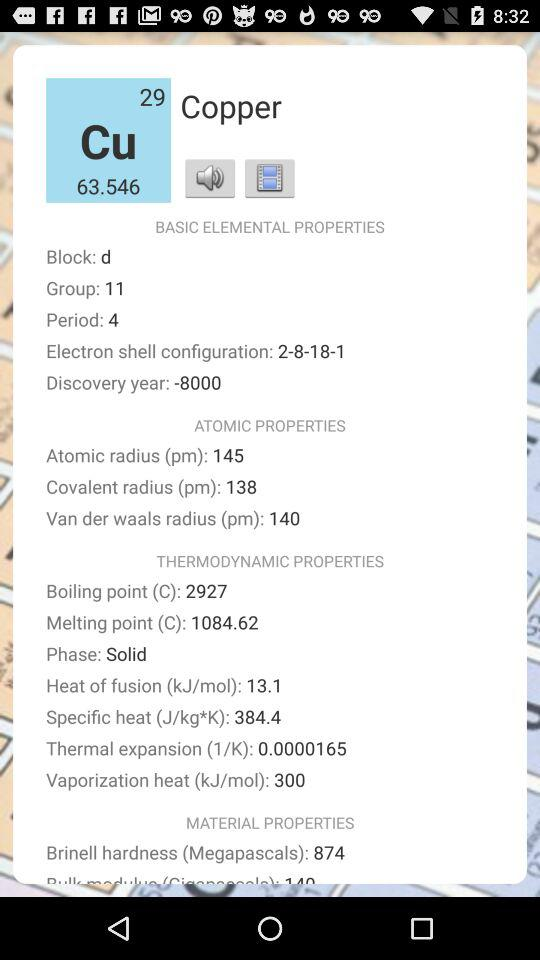What is the atomic radius? The atomic radius is 145 pm. 